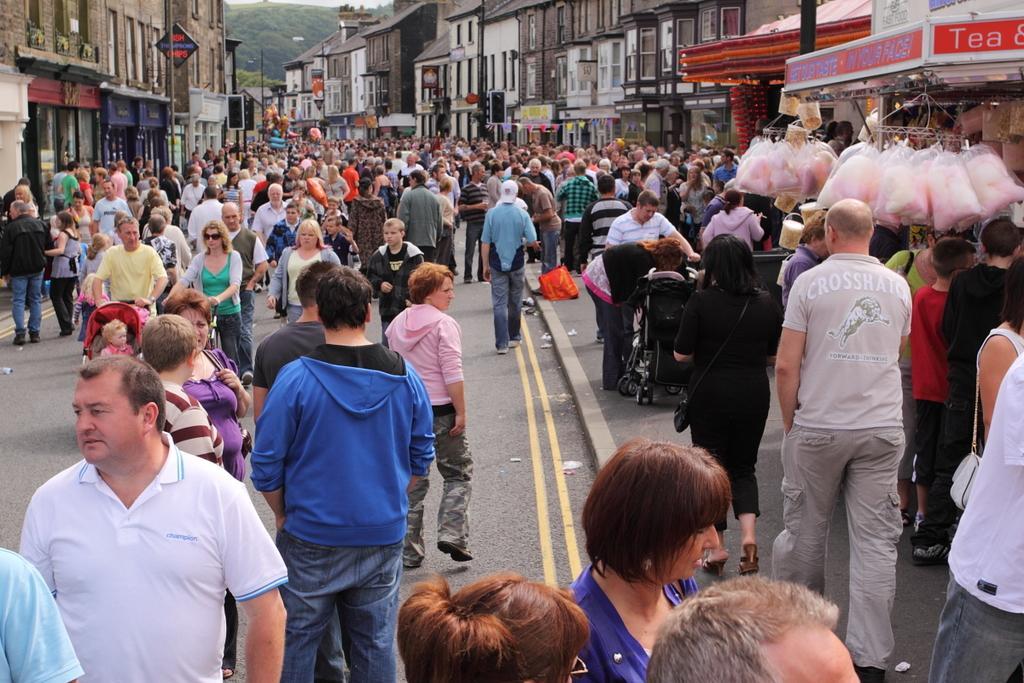Could you give a brief overview of what you see in this image? This picture describes about group of people, few are standing and few are walking, in the background we can see few buildings, sign boards and poles, and also we can see few baby carts. 